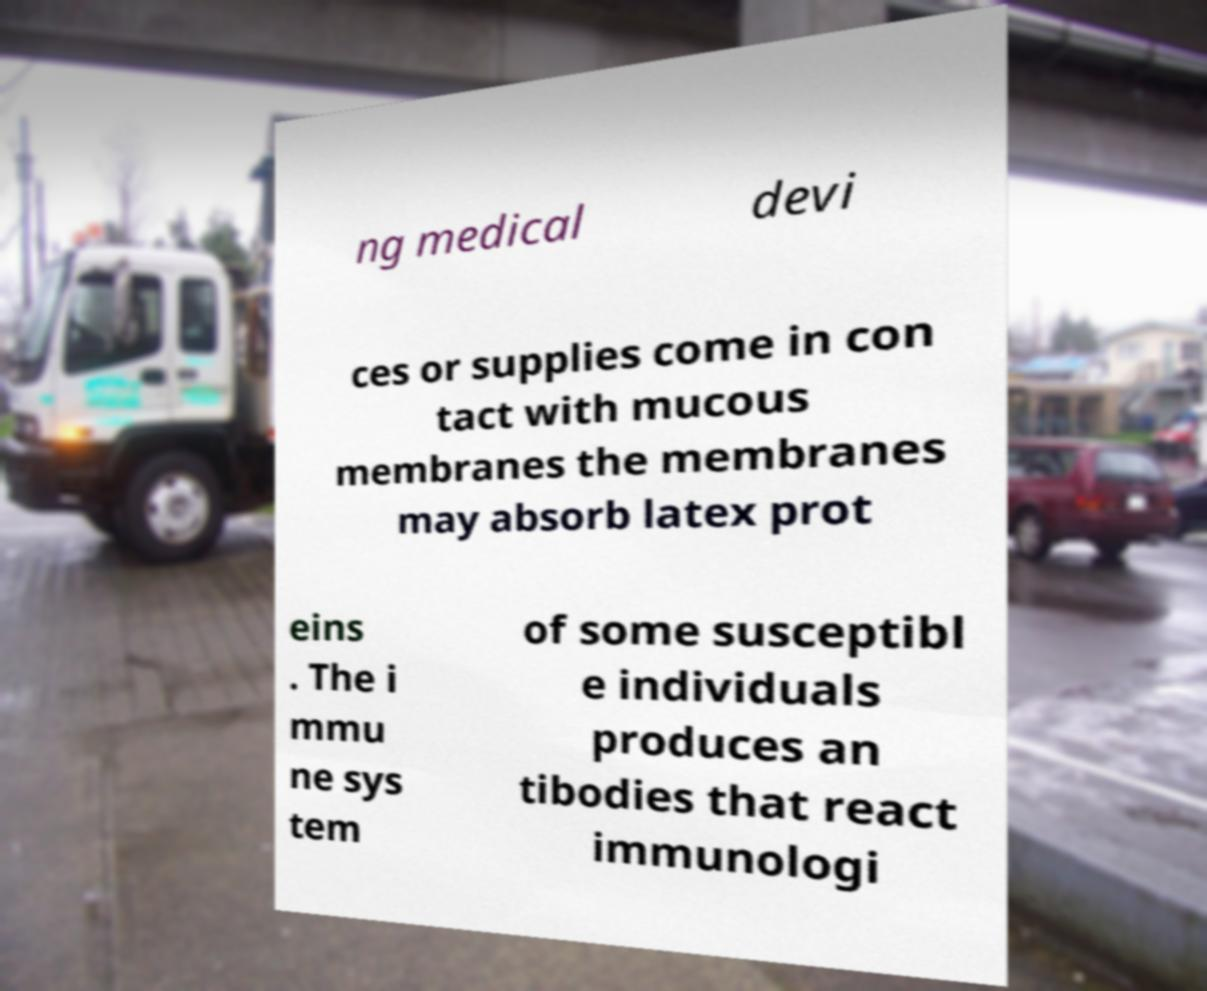Can you read and provide the text displayed in the image?This photo seems to have some interesting text. Can you extract and type it out for me? ng medical devi ces or supplies come in con tact with mucous membranes the membranes may absorb latex prot eins . The i mmu ne sys tem of some susceptibl e individuals produces an tibodies that react immunologi 